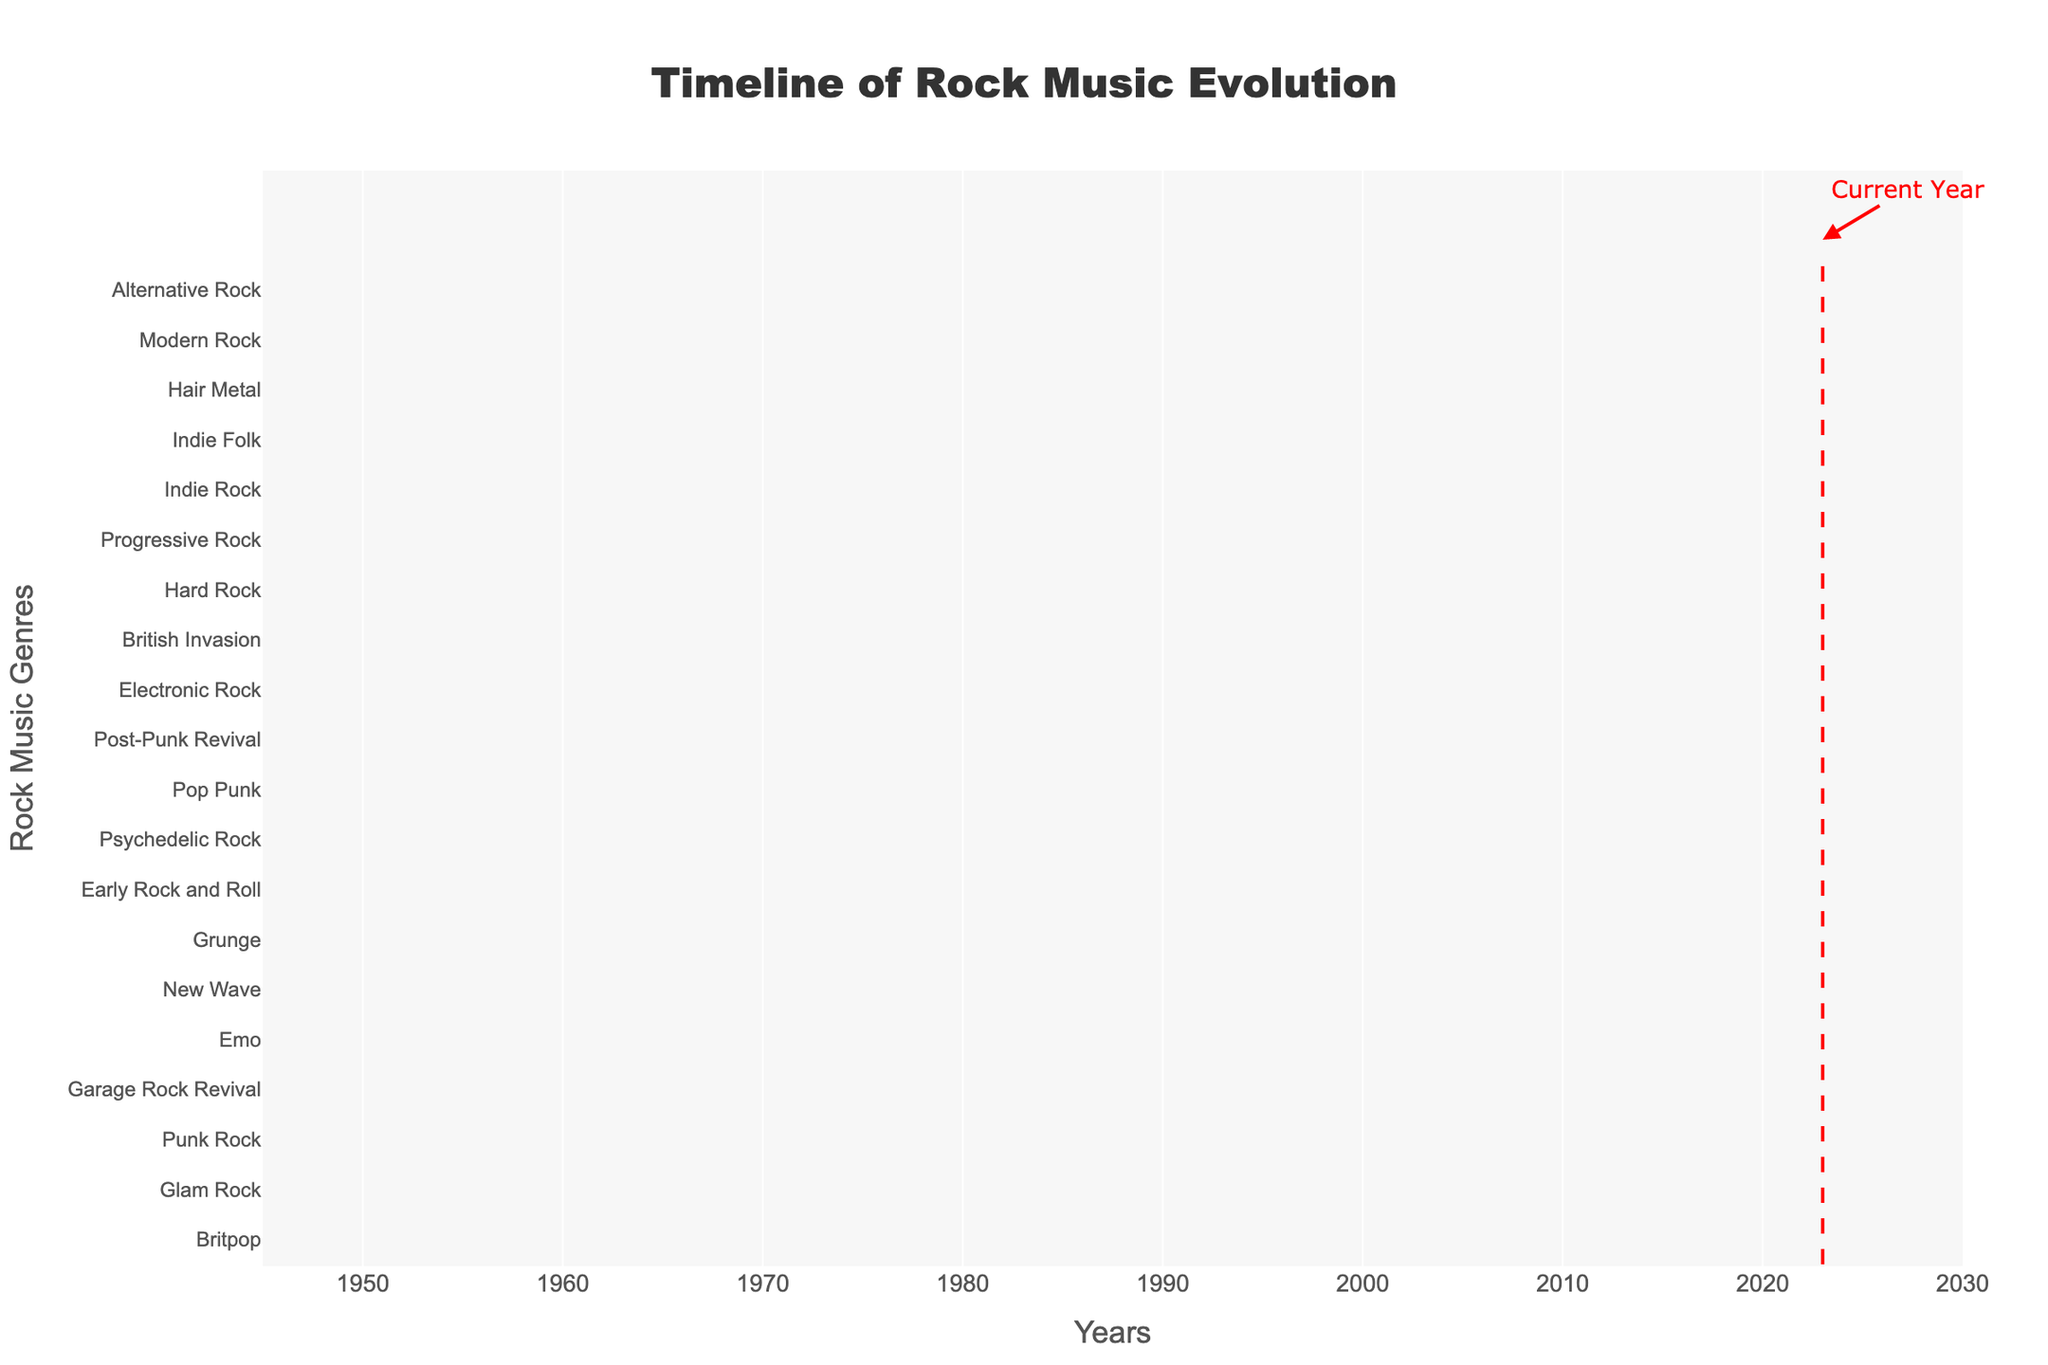What's the title of the Gantt Chart? The title is typically displayed at the top center of the chart. In this case, it's mentioned as part of the layout customization. The title is "Timeline of Rock Music Evolution."
Answer: Timeline of Rock Music Evolution Over which period does the "Early Rock and Roll" genre span? To find this, look at the "Early Rock and Roll" bar on the chart and note the start and end dates displayed in the hovertext or along the x-axis.
Answer: 1950-1960 Which genre started immediately after the "Early Rock and Roll" period ended? Observe the timeline and check which genre began in 1960, immediately following the end of "Early Rock and Roll." This information is evidenced by the bars' start and end dates.
Answer: British Invasion What is the duration of the "Grunge" genre? Identify the start and end dates of the "Grunge" genre bar and calculate the difference in years between 1988 and 1997.
Answer: 9 years Which genre lasted the longest among those listed? Compare the durations of all the genres by looking at the width of each bar or by calculating the difference between start and end dates for each genre. The genre with the longest bar is the longest-lasting genre.
Answer: Modern Rock How many genres overlapped the period from 1990 to 2000? Check all the bars that span the years 1990 to 2000 even partially. Count each genre that falls within or overlaps this period.
Answer: 7 genres Which genre ended right before the "Garage Rock Revival" began? Determine the start year of "Garage Rock Revival" and look for the genre whose end year is immediately before this start year. In this case, look for the genre ending in 2000.
Answer: Pop Punk How does the duration of "Britpop" (1993-1997) compare to "Glam Rock" (1970-1976)? Calculate the duration of both genres in years (subtract start year from end year) and then compare their lengths. Britpop lasts 4 years (1993-1997) while Glam Rock lasts 6 years (1970-1976).
Answer: Britpop: 4 years, Glam Rock: 6 years What were the concurrent genres during the "New Wave" period (1977-1986)? Identify which genres were active during any part of the "New Wave" period by checking the overlaps visually on the chart.
Answer: Hard Rock, Progressive Rock, Punk Rock, Hair Metal 